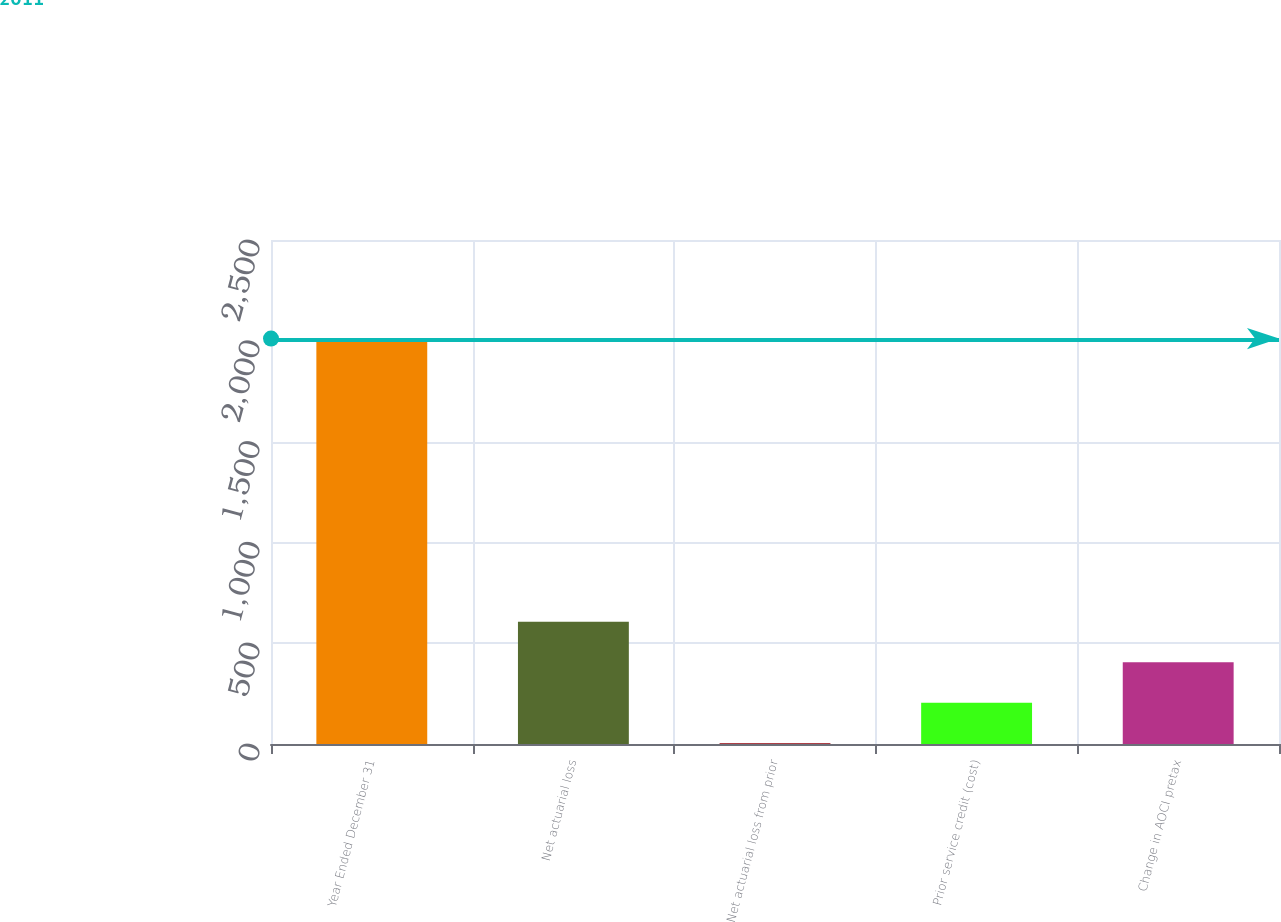Convert chart. <chart><loc_0><loc_0><loc_500><loc_500><bar_chart><fcel>Year Ended December 31<fcel>Net actuarial loss<fcel>Net actuarial loss from prior<fcel>Prior service credit (cost)<fcel>Change in AOCI pretax<nl><fcel>2011<fcel>606.1<fcel>4<fcel>204.7<fcel>405.4<nl></chart> 